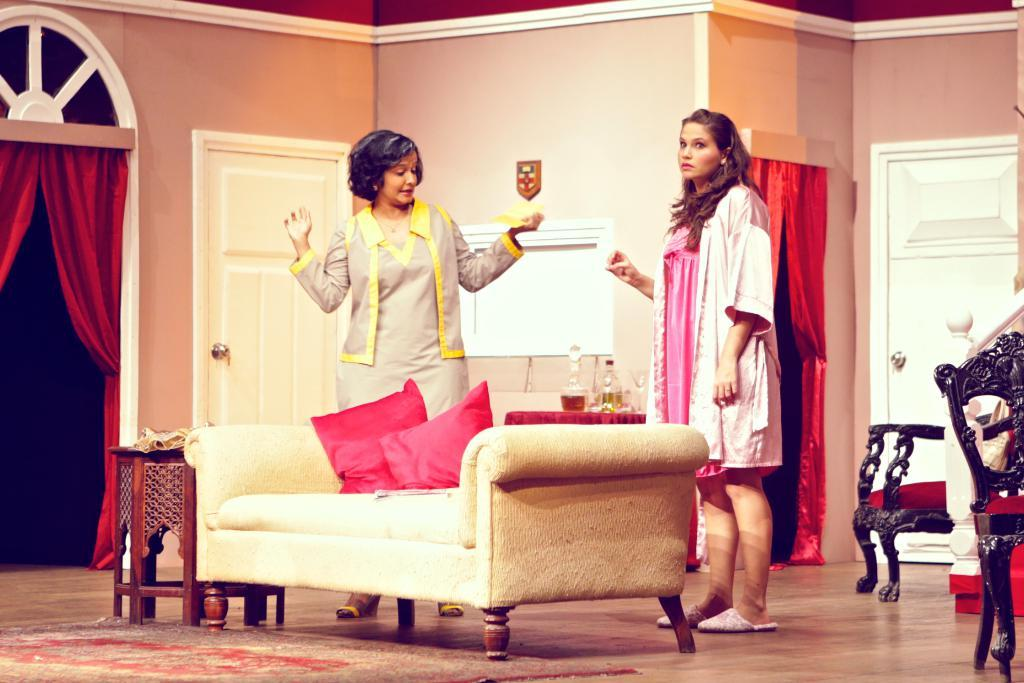How many women are in the image? There are two women standing in the image. What type of furniture is present in the image? There is a sofa in the image, and chairs are visible in the background. What can be found on the sofa? There are cushions on the sofa. What type of window treatment is present in the background of the image? There are curtains in the background of the image. What architectural feature is visible in the background of the image? There is a door in the background of the image. What type of tooth is visible in the image? There is no tooth present in the image. Are the women's friends visible in the image? The provided facts do not mention any friends, so we cannot determine if they are visible in the image. 